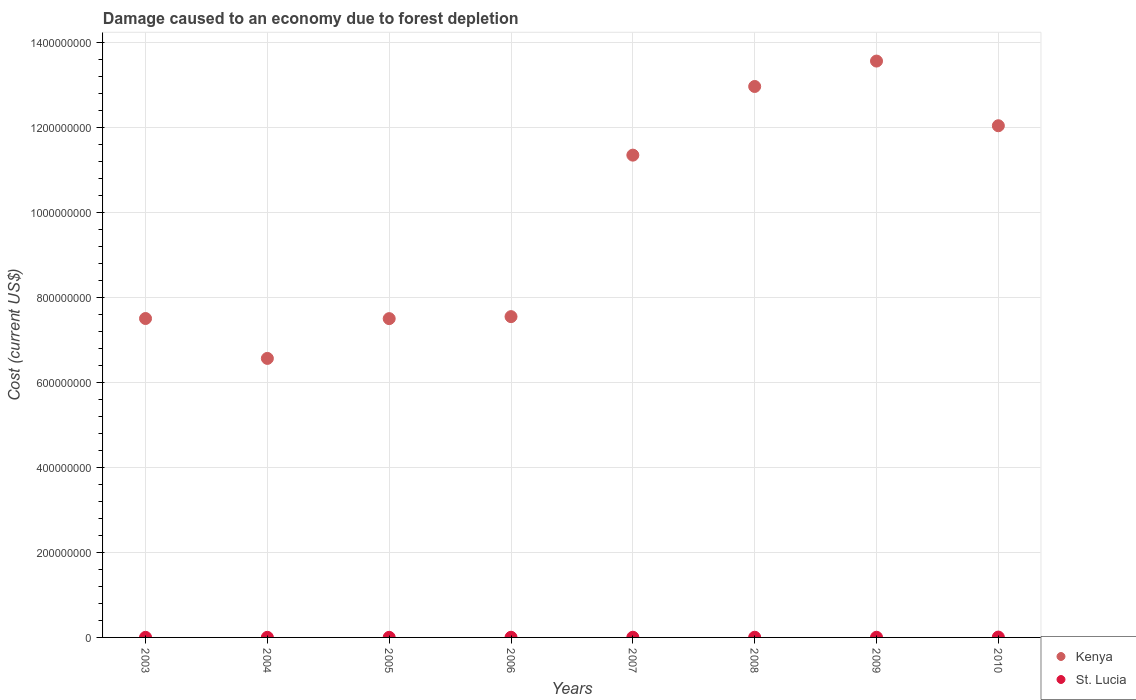How many different coloured dotlines are there?
Your answer should be compact. 2. What is the cost of damage caused due to forest depletion in Kenya in 2010?
Ensure brevity in your answer.  1.20e+09. Across all years, what is the maximum cost of damage caused due to forest depletion in Kenya?
Provide a short and direct response. 1.36e+09. Across all years, what is the minimum cost of damage caused due to forest depletion in Kenya?
Offer a very short reply. 6.57e+08. In which year was the cost of damage caused due to forest depletion in St. Lucia maximum?
Give a very brief answer. 2010. In which year was the cost of damage caused due to forest depletion in Kenya minimum?
Your answer should be very brief. 2004. What is the total cost of damage caused due to forest depletion in St. Lucia in the graph?
Your answer should be very brief. 3.13e+06. What is the difference between the cost of damage caused due to forest depletion in St. Lucia in 2007 and that in 2008?
Offer a terse response. -2.65e+04. What is the difference between the cost of damage caused due to forest depletion in St. Lucia in 2005 and the cost of damage caused due to forest depletion in Kenya in 2008?
Provide a succinct answer. -1.30e+09. What is the average cost of damage caused due to forest depletion in Kenya per year?
Make the answer very short. 9.88e+08. In the year 2010, what is the difference between the cost of damage caused due to forest depletion in St. Lucia and cost of damage caused due to forest depletion in Kenya?
Make the answer very short. -1.20e+09. What is the ratio of the cost of damage caused due to forest depletion in Kenya in 2003 to that in 2008?
Your answer should be compact. 0.58. Is the cost of damage caused due to forest depletion in St. Lucia in 2004 less than that in 2007?
Make the answer very short. Yes. Is the difference between the cost of damage caused due to forest depletion in St. Lucia in 2005 and 2006 greater than the difference between the cost of damage caused due to forest depletion in Kenya in 2005 and 2006?
Give a very brief answer. Yes. What is the difference between the highest and the second highest cost of damage caused due to forest depletion in St. Lucia?
Provide a short and direct response. 4.05e+05. What is the difference between the highest and the lowest cost of damage caused due to forest depletion in Kenya?
Keep it short and to the point. 7.00e+08. In how many years, is the cost of damage caused due to forest depletion in Kenya greater than the average cost of damage caused due to forest depletion in Kenya taken over all years?
Keep it short and to the point. 4. Does the cost of damage caused due to forest depletion in St. Lucia monotonically increase over the years?
Provide a short and direct response. No. Is the cost of damage caused due to forest depletion in Kenya strictly less than the cost of damage caused due to forest depletion in St. Lucia over the years?
Provide a short and direct response. No. How many dotlines are there?
Provide a succinct answer. 2. What is the difference between two consecutive major ticks on the Y-axis?
Provide a succinct answer. 2.00e+08. Does the graph contain any zero values?
Offer a very short reply. No. Does the graph contain grids?
Offer a very short reply. Yes. How many legend labels are there?
Your answer should be very brief. 2. What is the title of the graph?
Provide a short and direct response. Damage caused to an economy due to forest depletion. What is the label or title of the Y-axis?
Your answer should be very brief. Cost (current US$). What is the Cost (current US$) in Kenya in 2003?
Provide a succinct answer. 7.51e+08. What is the Cost (current US$) of St. Lucia in 2003?
Your answer should be compact. 2.35e+05. What is the Cost (current US$) in Kenya in 2004?
Your answer should be compact. 6.57e+08. What is the Cost (current US$) in St. Lucia in 2004?
Ensure brevity in your answer.  2.47e+05. What is the Cost (current US$) in Kenya in 2005?
Ensure brevity in your answer.  7.50e+08. What is the Cost (current US$) in St. Lucia in 2005?
Provide a succinct answer. 2.37e+05. What is the Cost (current US$) in Kenya in 2006?
Ensure brevity in your answer.  7.55e+08. What is the Cost (current US$) in St. Lucia in 2006?
Your answer should be very brief. 3.53e+05. What is the Cost (current US$) of Kenya in 2007?
Your response must be concise. 1.14e+09. What is the Cost (current US$) in St. Lucia in 2007?
Keep it short and to the point. 4.03e+05. What is the Cost (current US$) in Kenya in 2008?
Keep it short and to the point. 1.30e+09. What is the Cost (current US$) of St. Lucia in 2008?
Your response must be concise. 4.30e+05. What is the Cost (current US$) of Kenya in 2009?
Keep it short and to the point. 1.36e+09. What is the Cost (current US$) of St. Lucia in 2009?
Make the answer very short. 3.93e+05. What is the Cost (current US$) in Kenya in 2010?
Give a very brief answer. 1.20e+09. What is the Cost (current US$) of St. Lucia in 2010?
Ensure brevity in your answer.  8.35e+05. Across all years, what is the maximum Cost (current US$) in Kenya?
Your answer should be compact. 1.36e+09. Across all years, what is the maximum Cost (current US$) of St. Lucia?
Provide a short and direct response. 8.35e+05. Across all years, what is the minimum Cost (current US$) of Kenya?
Offer a very short reply. 6.57e+08. Across all years, what is the minimum Cost (current US$) in St. Lucia?
Ensure brevity in your answer.  2.35e+05. What is the total Cost (current US$) of Kenya in the graph?
Your answer should be compact. 7.90e+09. What is the total Cost (current US$) in St. Lucia in the graph?
Give a very brief answer. 3.13e+06. What is the difference between the Cost (current US$) of Kenya in 2003 and that in 2004?
Ensure brevity in your answer.  9.39e+07. What is the difference between the Cost (current US$) of St. Lucia in 2003 and that in 2004?
Your response must be concise. -1.20e+04. What is the difference between the Cost (current US$) of Kenya in 2003 and that in 2005?
Provide a succinct answer. 2.71e+05. What is the difference between the Cost (current US$) of St. Lucia in 2003 and that in 2005?
Your answer should be very brief. -1808.31. What is the difference between the Cost (current US$) of Kenya in 2003 and that in 2006?
Ensure brevity in your answer.  -4.44e+06. What is the difference between the Cost (current US$) in St. Lucia in 2003 and that in 2006?
Keep it short and to the point. -1.18e+05. What is the difference between the Cost (current US$) of Kenya in 2003 and that in 2007?
Keep it short and to the point. -3.84e+08. What is the difference between the Cost (current US$) of St. Lucia in 2003 and that in 2007?
Your response must be concise. -1.68e+05. What is the difference between the Cost (current US$) of Kenya in 2003 and that in 2008?
Give a very brief answer. -5.46e+08. What is the difference between the Cost (current US$) of St. Lucia in 2003 and that in 2008?
Your response must be concise. -1.95e+05. What is the difference between the Cost (current US$) of Kenya in 2003 and that in 2009?
Ensure brevity in your answer.  -6.06e+08. What is the difference between the Cost (current US$) in St. Lucia in 2003 and that in 2009?
Your answer should be compact. -1.58e+05. What is the difference between the Cost (current US$) of Kenya in 2003 and that in 2010?
Provide a succinct answer. -4.54e+08. What is the difference between the Cost (current US$) in St. Lucia in 2003 and that in 2010?
Provide a short and direct response. -6.00e+05. What is the difference between the Cost (current US$) in Kenya in 2004 and that in 2005?
Provide a succinct answer. -9.36e+07. What is the difference between the Cost (current US$) in St. Lucia in 2004 and that in 2005?
Keep it short and to the point. 1.02e+04. What is the difference between the Cost (current US$) of Kenya in 2004 and that in 2006?
Your answer should be compact. -9.83e+07. What is the difference between the Cost (current US$) of St. Lucia in 2004 and that in 2006?
Make the answer very short. -1.06e+05. What is the difference between the Cost (current US$) of Kenya in 2004 and that in 2007?
Keep it short and to the point. -4.78e+08. What is the difference between the Cost (current US$) of St. Lucia in 2004 and that in 2007?
Your answer should be very brief. -1.56e+05. What is the difference between the Cost (current US$) of Kenya in 2004 and that in 2008?
Offer a terse response. -6.40e+08. What is the difference between the Cost (current US$) in St. Lucia in 2004 and that in 2008?
Your answer should be compact. -1.83e+05. What is the difference between the Cost (current US$) in Kenya in 2004 and that in 2009?
Your answer should be very brief. -7.00e+08. What is the difference between the Cost (current US$) in St. Lucia in 2004 and that in 2009?
Your answer should be compact. -1.46e+05. What is the difference between the Cost (current US$) of Kenya in 2004 and that in 2010?
Provide a short and direct response. -5.48e+08. What is the difference between the Cost (current US$) in St. Lucia in 2004 and that in 2010?
Make the answer very short. -5.88e+05. What is the difference between the Cost (current US$) of Kenya in 2005 and that in 2006?
Ensure brevity in your answer.  -4.71e+06. What is the difference between the Cost (current US$) of St. Lucia in 2005 and that in 2006?
Make the answer very short. -1.16e+05. What is the difference between the Cost (current US$) of Kenya in 2005 and that in 2007?
Your response must be concise. -3.85e+08. What is the difference between the Cost (current US$) of St. Lucia in 2005 and that in 2007?
Your response must be concise. -1.66e+05. What is the difference between the Cost (current US$) of Kenya in 2005 and that in 2008?
Your response must be concise. -5.46e+08. What is the difference between the Cost (current US$) in St. Lucia in 2005 and that in 2008?
Your response must be concise. -1.93e+05. What is the difference between the Cost (current US$) of Kenya in 2005 and that in 2009?
Your response must be concise. -6.06e+08. What is the difference between the Cost (current US$) of St. Lucia in 2005 and that in 2009?
Your answer should be compact. -1.56e+05. What is the difference between the Cost (current US$) of Kenya in 2005 and that in 2010?
Your response must be concise. -4.54e+08. What is the difference between the Cost (current US$) in St. Lucia in 2005 and that in 2010?
Your answer should be compact. -5.98e+05. What is the difference between the Cost (current US$) in Kenya in 2006 and that in 2007?
Your response must be concise. -3.80e+08. What is the difference between the Cost (current US$) in St. Lucia in 2006 and that in 2007?
Offer a very short reply. -5.04e+04. What is the difference between the Cost (current US$) in Kenya in 2006 and that in 2008?
Keep it short and to the point. -5.42e+08. What is the difference between the Cost (current US$) of St. Lucia in 2006 and that in 2008?
Make the answer very short. -7.69e+04. What is the difference between the Cost (current US$) of Kenya in 2006 and that in 2009?
Keep it short and to the point. -6.01e+08. What is the difference between the Cost (current US$) of St. Lucia in 2006 and that in 2009?
Make the answer very short. -4.03e+04. What is the difference between the Cost (current US$) in Kenya in 2006 and that in 2010?
Make the answer very short. -4.49e+08. What is the difference between the Cost (current US$) in St. Lucia in 2006 and that in 2010?
Give a very brief answer. -4.82e+05. What is the difference between the Cost (current US$) of Kenya in 2007 and that in 2008?
Your response must be concise. -1.62e+08. What is the difference between the Cost (current US$) of St. Lucia in 2007 and that in 2008?
Your answer should be very brief. -2.65e+04. What is the difference between the Cost (current US$) of Kenya in 2007 and that in 2009?
Make the answer very short. -2.21e+08. What is the difference between the Cost (current US$) of St. Lucia in 2007 and that in 2009?
Your answer should be very brief. 1.01e+04. What is the difference between the Cost (current US$) of Kenya in 2007 and that in 2010?
Keep it short and to the point. -6.92e+07. What is the difference between the Cost (current US$) in St. Lucia in 2007 and that in 2010?
Offer a very short reply. -4.32e+05. What is the difference between the Cost (current US$) of Kenya in 2008 and that in 2009?
Offer a terse response. -5.98e+07. What is the difference between the Cost (current US$) of St. Lucia in 2008 and that in 2009?
Your response must be concise. 3.67e+04. What is the difference between the Cost (current US$) in Kenya in 2008 and that in 2010?
Provide a short and direct response. 9.24e+07. What is the difference between the Cost (current US$) of St. Lucia in 2008 and that in 2010?
Offer a very short reply. -4.05e+05. What is the difference between the Cost (current US$) in Kenya in 2009 and that in 2010?
Your response must be concise. 1.52e+08. What is the difference between the Cost (current US$) in St. Lucia in 2009 and that in 2010?
Give a very brief answer. -4.42e+05. What is the difference between the Cost (current US$) of Kenya in 2003 and the Cost (current US$) of St. Lucia in 2004?
Give a very brief answer. 7.50e+08. What is the difference between the Cost (current US$) in Kenya in 2003 and the Cost (current US$) in St. Lucia in 2005?
Ensure brevity in your answer.  7.50e+08. What is the difference between the Cost (current US$) of Kenya in 2003 and the Cost (current US$) of St. Lucia in 2006?
Your answer should be compact. 7.50e+08. What is the difference between the Cost (current US$) of Kenya in 2003 and the Cost (current US$) of St. Lucia in 2007?
Your answer should be very brief. 7.50e+08. What is the difference between the Cost (current US$) in Kenya in 2003 and the Cost (current US$) in St. Lucia in 2008?
Your answer should be compact. 7.50e+08. What is the difference between the Cost (current US$) of Kenya in 2003 and the Cost (current US$) of St. Lucia in 2009?
Your response must be concise. 7.50e+08. What is the difference between the Cost (current US$) of Kenya in 2003 and the Cost (current US$) of St. Lucia in 2010?
Your response must be concise. 7.50e+08. What is the difference between the Cost (current US$) of Kenya in 2004 and the Cost (current US$) of St. Lucia in 2005?
Your answer should be compact. 6.56e+08. What is the difference between the Cost (current US$) in Kenya in 2004 and the Cost (current US$) in St. Lucia in 2006?
Provide a short and direct response. 6.56e+08. What is the difference between the Cost (current US$) of Kenya in 2004 and the Cost (current US$) of St. Lucia in 2007?
Offer a very short reply. 6.56e+08. What is the difference between the Cost (current US$) of Kenya in 2004 and the Cost (current US$) of St. Lucia in 2008?
Your response must be concise. 6.56e+08. What is the difference between the Cost (current US$) in Kenya in 2004 and the Cost (current US$) in St. Lucia in 2009?
Provide a short and direct response. 6.56e+08. What is the difference between the Cost (current US$) of Kenya in 2004 and the Cost (current US$) of St. Lucia in 2010?
Make the answer very short. 6.56e+08. What is the difference between the Cost (current US$) in Kenya in 2005 and the Cost (current US$) in St. Lucia in 2006?
Ensure brevity in your answer.  7.50e+08. What is the difference between the Cost (current US$) in Kenya in 2005 and the Cost (current US$) in St. Lucia in 2007?
Offer a very short reply. 7.50e+08. What is the difference between the Cost (current US$) in Kenya in 2005 and the Cost (current US$) in St. Lucia in 2008?
Your response must be concise. 7.50e+08. What is the difference between the Cost (current US$) of Kenya in 2005 and the Cost (current US$) of St. Lucia in 2009?
Provide a succinct answer. 7.50e+08. What is the difference between the Cost (current US$) of Kenya in 2005 and the Cost (current US$) of St. Lucia in 2010?
Offer a terse response. 7.49e+08. What is the difference between the Cost (current US$) in Kenya in 2006 and the Cost (current US$) in St. Lucia in 2007?
Your answer should be compact. 7.55e+08. What is the difference between the Cost (current US$) of Kenya in 2006 and the Cost (current US$) of St. Lucia in 2008?
Your response must be concise. 7.55e+08. What is the difference between the Cost (current US$) in Kenya in 2006 and the Cost (current US$) in St. Lucia in 2009?
Ensure brevity in your answer.  7.55e+08. What is the difference between the Cost (current US$) in Kenya in 2006 and the Cost (current US$) in St. Lucia in 2010?
Provide a short and direct response. 7.54e+08. What is the difference between the Cost (current US$) in Kenya in 2007 and the Cost (current US$) in St. Lucia in 2008?
Your response must be concise. 1.13e+09. What is the difference between the Cost (current US$) of Kenya in 2007 and the Cost (current US$) of St. Lucia in 2009?
Offer a terse response. 1.13e+09. What is the difference between the Cost (current US$) of Kenya in 2007 and the Cost (current US$) of St. Lucia in 2010?
Your answer should be very brief. 1.13e+09. What is the difference between the Cost (current US$) of Kenya in 2008 and the Cost (current US$) of St. Lucia in 2009?
Offer a very short reply. 1.30e+09. What is the difference between the Cost (current US$) in Kenya in 2008 and the Cost (current US$) in St. Lucia in 2010?
Ensure brevity in your answer.  1.30e+09. What is the difference between the Cost (current US$) of Kenya in 2009 and the Cost (current US$) of St. Lucia in 2010?
Ensure brevity in your answer.  1.36e+09. What is the average Cost (current US$) in Kenya per year?
Your answer should be very brief. 9.88e+08. What is the average Cost (current US$) in St. Lucia per year?
Ensure brevity in your answer.  3.92e+05. In the year 2003, what is the difference between the Cost (current US$) in Kenya and Cost (current US$) in St. Lucia?
Make the answer very short. 7.50e+08. In the year 2004, what is the difference between the Cost (current US$) in Kenya and Cost (current US$) in St. Lucia?
Your response must be concise. 6.56e+08. In the year 2005, what is the difference between the Cost (current US$) in Kenya and Cost (current US$) in St. Lucia?
Ensure brevity in your answer.  7.50e+08. In the year 2006, what is the difference between the Cost (current US$) in Kenya and Cost (current US$) in St. Lucia?
Give a very brief answer. 7.55e+08. In the year 2007, what is the difference between the Cost (current US$) in Kenya and Cost (current US$) in St. Lucia?
Offer a terse response. 1.13e+09. In the year 2008, what is the difference between the Cost (current US$) in Kenya and Cost (current US$) in St. Lucia?
Your answer should be compact. 1.30e+09. In the year 2009, what is the difference between the Cost (current US$) of Kenya and Cost (current US$) of St. Lucia?
Your answer should be very brief. 1.36e+09. In the year 2010, what is the difference between the Cost (current US$) of Kenya and Cost (current US$) of St. Lucia?
Ensure brevity in your answer.  1.20e+09. What is the ratio of the Cost (current US$) of Kenya in 2003 to that in 2004?
Your answer should be very brief. 1.14. What is the ratio of the Cost (current US$) in St. Lucia in 2003 to that in 2004?
Keep it short and to the point. 0.95. What is the ratio of the Cost (current US$) of Kenya in 2003 to that in 2006?
Give a very brief answer. 0.99. What is the ratio of the Cost (current US$) in St. Lucia in 2003 to that in 2006?
Offer a very short reply. 0.67. What is the ratio of the Cost (current US$) of Kenya in 2003 to that in 2007?
Ensure brevity in your answer.  0.66. What is the ratio of the Cost (current US$) of St. Lucia in 2003 to that in 2007?
Your answer should be very brief. 0.58. What is the ratio of the Cost (current US$) of Kenya in 2003 to that in 2008?
Offer a terse response. 0.58. What is the ratio of the Cost (current US$) in St. Lucia in 2003 to that in 2008?
Make the answer very short. 0.55. What is the ratio of the Cost (current US$) of Kenya in 2003 to that in 2009?
Your answer should be compact. 0.55. What is the ratio of the Cost (current US$) in St. Lucia in 2003 to that in 2009?
Offer a terse response. 0.6. What is the ratio of the Cost (current US$) of Kenya in 2003 to that in 2010?
Your answer should be compact. 0.62. What is the ratio of the Cost (current US$) of St. Lucia in 2003 to that in 2010?
Your answer should be very brief. 0.28. What is the ratio of the Cost (current US$) of Kenya in 2004 to that in 2005?
Provide a succinct answer. 0.88. What is the ratio of the Cost (current US$) in St. Lucia in 2004 to that in 2005?
Your answer should be compact. 1.04. What is the ratio of the Cost (current US$) in Kenya in 2004 to that in 2006?
Your answer should be very brief. 0.87. What is the ratio of the Cost (current US$) in St. Lucia in 2004 to that in 2006?
Your response must be concise. 0.7. What is the ratio of the Cost (current US$) in Kenya in 2004 to that in 2007?
Offer a terse response. 0.58. What is the ratio of the Cost (current US$) in St. Lucia in 2004 to that in 2007?
Ensure brevity in your answer.  0.61. What is the ratio of the Cost (current US$) of Kenya in 2004 to that in 2008?
Your response must be concise. 0.51. What is the ratio of the Cost (current US$) in St. Lucia in 2004 to that in 2008?
Offer a terse response. 0.57. What is the ratio of the Cost (current US$) of Kenya in 2004 to that in 2009?
Provide a short and direct response. 0.48. What is the ratio of the Cost (current US$) of St. Lucia in 2004 to that in 2009?
Provide a short and direct response. 0.63. What is the ratio of the Cost (current US$) in Kenya in 2004 to that in 2010?
Offer a terse response. 0.55. What is the ratio of the Cost (current US$) of St. Lucia in 2004 to that in 2010?
Make the answer very short. 0.3. What is the ratio of the Cost (current US$) in St. Lucia in 2005 to that in 2006?
Your response must be concise. 0.67. What is the ratio of the Cost (current US$) of Kenya in 2005 to that in 2007?
Offer a very short reply. 0.66. What is the ratio of the Cost (current US$) of St. Lucia in 2005 to that in 2007?
Make the answer very short. 0.59. What is the ratio of the Cost (current US$) of Kenya in 2005 to that in 2008?
Offer a terse response. 0.58. What is the ratio of the Cost (current US$) of St. Lucia in 2005 to that in 2008?
Make the answer very short. 0.55. What is the ratio of the Cost (current US$) in Kenya in 2005 to that in 2009?
Provide a succinct answer. 0.55. What is the ratio of the Cost (current US$) of St. Lucia in 2005 to that in 2009?
Keep it short and to the point. 0.6. What is the ratio of the Cost (current US$) of Kenya in 2005 to that in 2010?
Provide a succinct answer. 0.62. What is the ratio of the Cost (current US$) of St. Lucia in 2005 to that in 2010?
Provide a succinct answer. 0.28. What is the ratio of the Cost (current US$) in Kenya in 2006 to that in 2007?
Provide a short and direct response. 0.67. What is the ratio of the Cost (current US$) of St. Lucia in 2006 to that in 2007?
Make the answer very short. 0.88. What is the ratio of the Cost (current US$) in Kenya in 2006 to that in 2008?
Provide a succinct answer. 0.58. What is the ratio of the Cost (current US$) of St. Lucia in 2006 to that in 2008?
Your answer should be compact. 0.82. What is the ratio of the Cost (current US$) of Kenya in 2006 to that in 2009?
Make the answer very short. 0.56. What is the ratio of the Cost (current US$) of St. Lucia in 2006 to that in 2009?
Your answer should be compact. 0.9. What is the ratio of the Cost (current US$) in Kenya in 2006 to that in 2010?
Your answer should be very brief. 0.63. What is the ratio of the Cost (current US$) in St. Lucia in 2006 to that in 2010?
Your response must be concise. 0.42. What is the ratio of the Cost (current US$) of Kenya in 2007 to that in 2008?
Your answer should be very brief. 0.88. What is the ratio of the Cost (current US$) in St. Lucia in 2007 to that in 2008?
Offer a terse response. 0.94. What is the ratio of the Cost (current US$) in Kenya in 2007 to that in 2009?
Keep it short and to the point. 0.84. What is the ratio of the Cost (current US$) in St. Lucia in 2007 to that in 2009?
Give a very brief answer. 1.03. What is the ratio of the Cost (current US$) of Kenya in 2007 to that in 2010?
Your response must be concise. 0.94. What is the ratio of the Cost (current US$) in St. Lucia in 2007 to that in 2010?
Offer a terse response. 0.48. What is the ratio of the Cost (current US$) of Kenya in 2008 to that in 2009?
Your answer should be compact. 0.96. What is the ratio of the Cost (current US$) of St. Lucia in 2008 to that in 2009?
Provide a succinct answer. 1.09. What is the ratio of the Cost (current US$) of Kenya in 2008 to that in 2010?
Ensure brevity in your answer.  1.08. What is the ratio of the Cost (current US$) of St. Lucia in 2008 to that in 2010?
Make the answer very short. 0.51. What is the ratio of the Cost (current US$) in Kenya in 2009 to that in 2010?
Offer a terse response. 1.13. What is the ratio of the Cost (current US$) of St. Lucia in 2009 to that in 2010?
Your answer should be very brief. 0.47. What is the difference between the highest and the second highest Cost (current US$) in Kenya?
Your answer should be compact. 5.98e+07. What is the difference between the highest and the second highest Cost (current US$) of St. Lucia?
Your answer should be compact. 4.05e+05. What is the difference between the highest and the lowest Cost (current US$) in Kenya?
Offer a very short reply. 7.00e+08. What is the difference between the highest and the lowest Cost (current US$) of St. Lucia?
Your answer should be compact. 6.00e+05. 